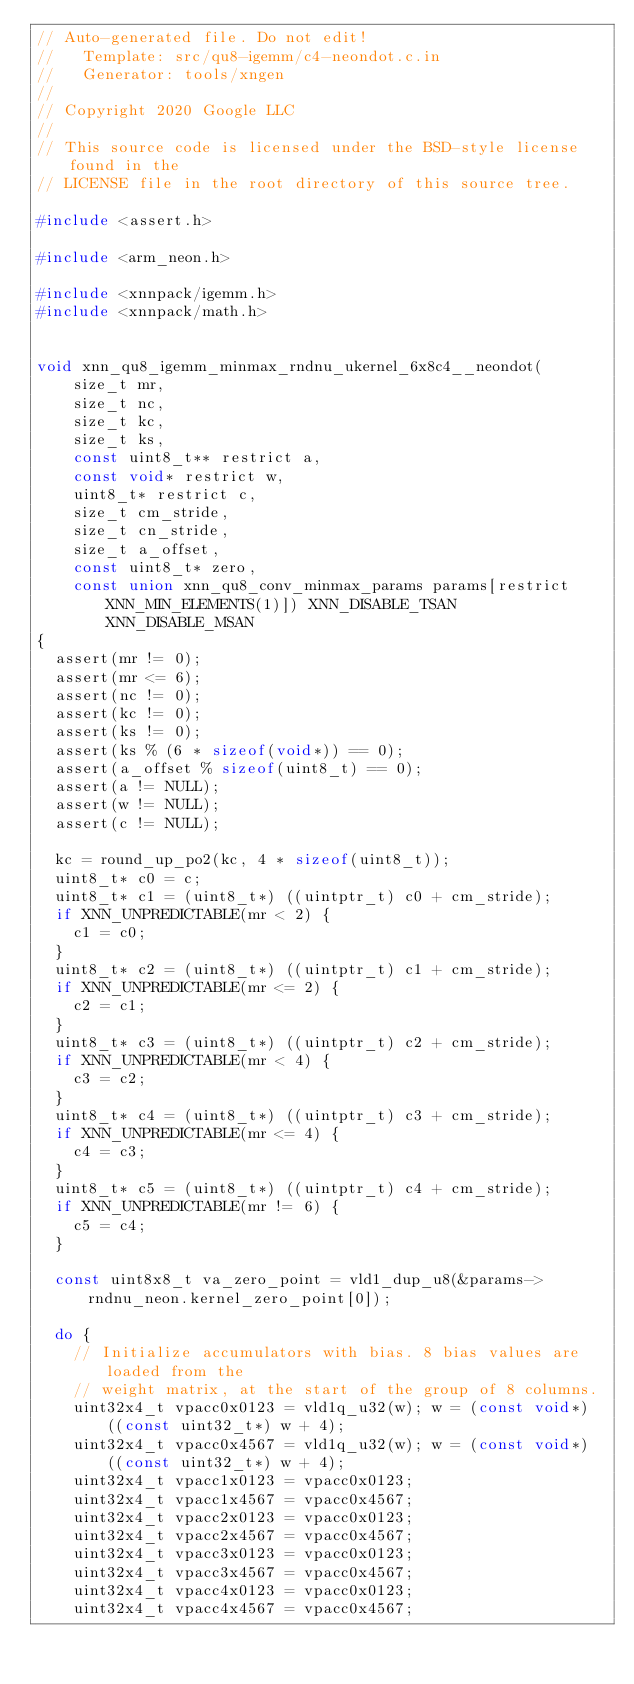<code> <loc_0><loc_0><loc_500><loc_500><_C_>// Auto-generated file. Do not edit!
//   Template: src/qu8-igemm/c4-neondot.c.in
//   Generator: tools/xngen
//
// Copyright 2020 Google LLC
//
// This source code is licensed under the BSD-style license found in the
// LICENSE file in the root directory of this source tree.

#include <assert.h>

#include <arm_neon.h>

#include <xnnpack/igemm.h>
#include <xnnpack/math.h>


void xnn_qu8_igemm_minmax_rndnu_ukernel_6x8c4__neondot(
    size_t mr,
    size_t nc,
    size_t kc,
    size_t ks,
    const uint8_t** restrict a,
    const void* restrict w,
    uint8_t* restrict c,
    size_t cm_stride,
    size_t cn_stride,
    size_t a_offset,
    const uint8_t* zero,
    const union xnn_qu8_conv_minmax_params params[restrict XNN_MIN_ELEMENTS(1)]) XNN_DISABLE_TSAN XNN_DISABLE_MSAN
{
  assert(mr != 0);
  assert(mr <= 6);
  assert(nc != 0);
  assert(kc != 0);
  assert(ks != 0);
  assert(ks % (6 * sizeof(void*)) == 0);
  assert(a_offset % sizeof(uint8_t) == 0);
  assert(a != NULL);
  assert(w != NULL);
  assert(c != NULL);

  kc = round_up_po2(kc, 4 * sizeof(uint8_t));
  uint8_t* c0 = c;
  uint8_t* c1 = (uint8_t*) ((uintptr_t) c0 + cm_stride);
  if XNN_UNPREDICTABLE(mr < 2) {
    c1 = c0;
  }
  uint8_t* c2 = (uint8_t*) ((uintptr_t) c1 + cm_stride);
  if XNN_UNPREDICTABLE(mr <= 2) {
    c2 = c1;
  }
  uint8_t* c3 = (uint8_t*) ((uintptr_t) c2 + cm_stride);
  if XNN_UNPREDICTABLE(mr < 4) {
    c3 = c2;
  }
  uint8_t* c4 = (uint8_t*) ((uintptr_t) c3 + cm_stride);
  if XNN_UNPREDICTABLE(mr <= 4) {
    c4 = c3;
  }
  uint8_t* c5 = (uint8_t*) ((uintptr_t) c4 + cm_stride);
  if XNN_UNPREDICTABLE(mr != 6) {
    c5 = c4;
  }

  const uint8x8_t va_zero_point = vld1_dup_u8(&params->rndnu_neon.kernel_zero_point[0]);

  do {
    // Initialize accumulators with bias. 8 bias values are loaded from the
    // weight matrix, at the start of the group of 8 columns.
    uint32x4_t vpacc0x0123 = vld1q_u32(w); w = (const void*) ((const uint32_t*) w + 4);
    uint32x4_t vpacc0x4567 = vld1q_u32(w); w = (const void*) ((const uint32_t*) w + 4);
    uint32x4_t vpacc1x0123 = vpacc0x0123;
    uint32x4_t vpacc1x4567 = vpacc0x4567;
    uint32x4_t vpacc2x0123 = vpacc0x0123;
    uint32x4_t vpacc2x4567 = vpacc0x4567;
    uint32x4_t vpacc3x0123 = vpacc0x0123;
    uint32x4_t vpacc3x4567 = vpacc0x4567;
    uint32x4_t vpacc4x0123 = vpacc0x0123;
    uint32x4_t vpacc4x4567 = vpacc0x4567;</code> 